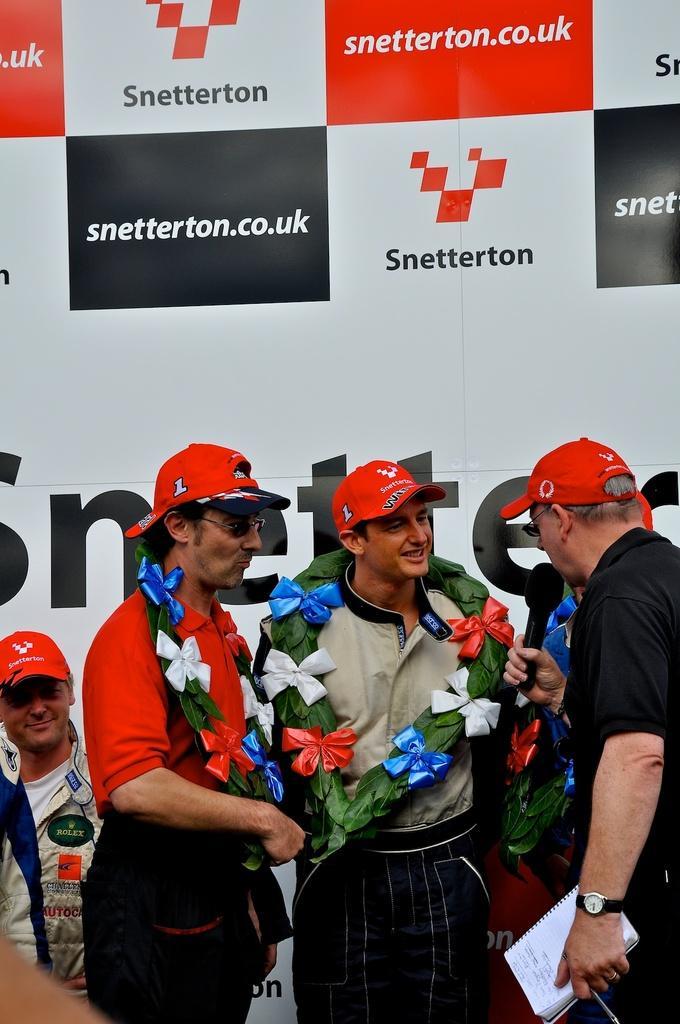Please provide a concise description of this image. In the picture I can see these people wearing red color caps are standing here, this person wearing black T-shirt, red cap is holding a mic and a book in his hands is standing on the right side of the image. In the background, we can see a white color banner on which we can see some text is written. 